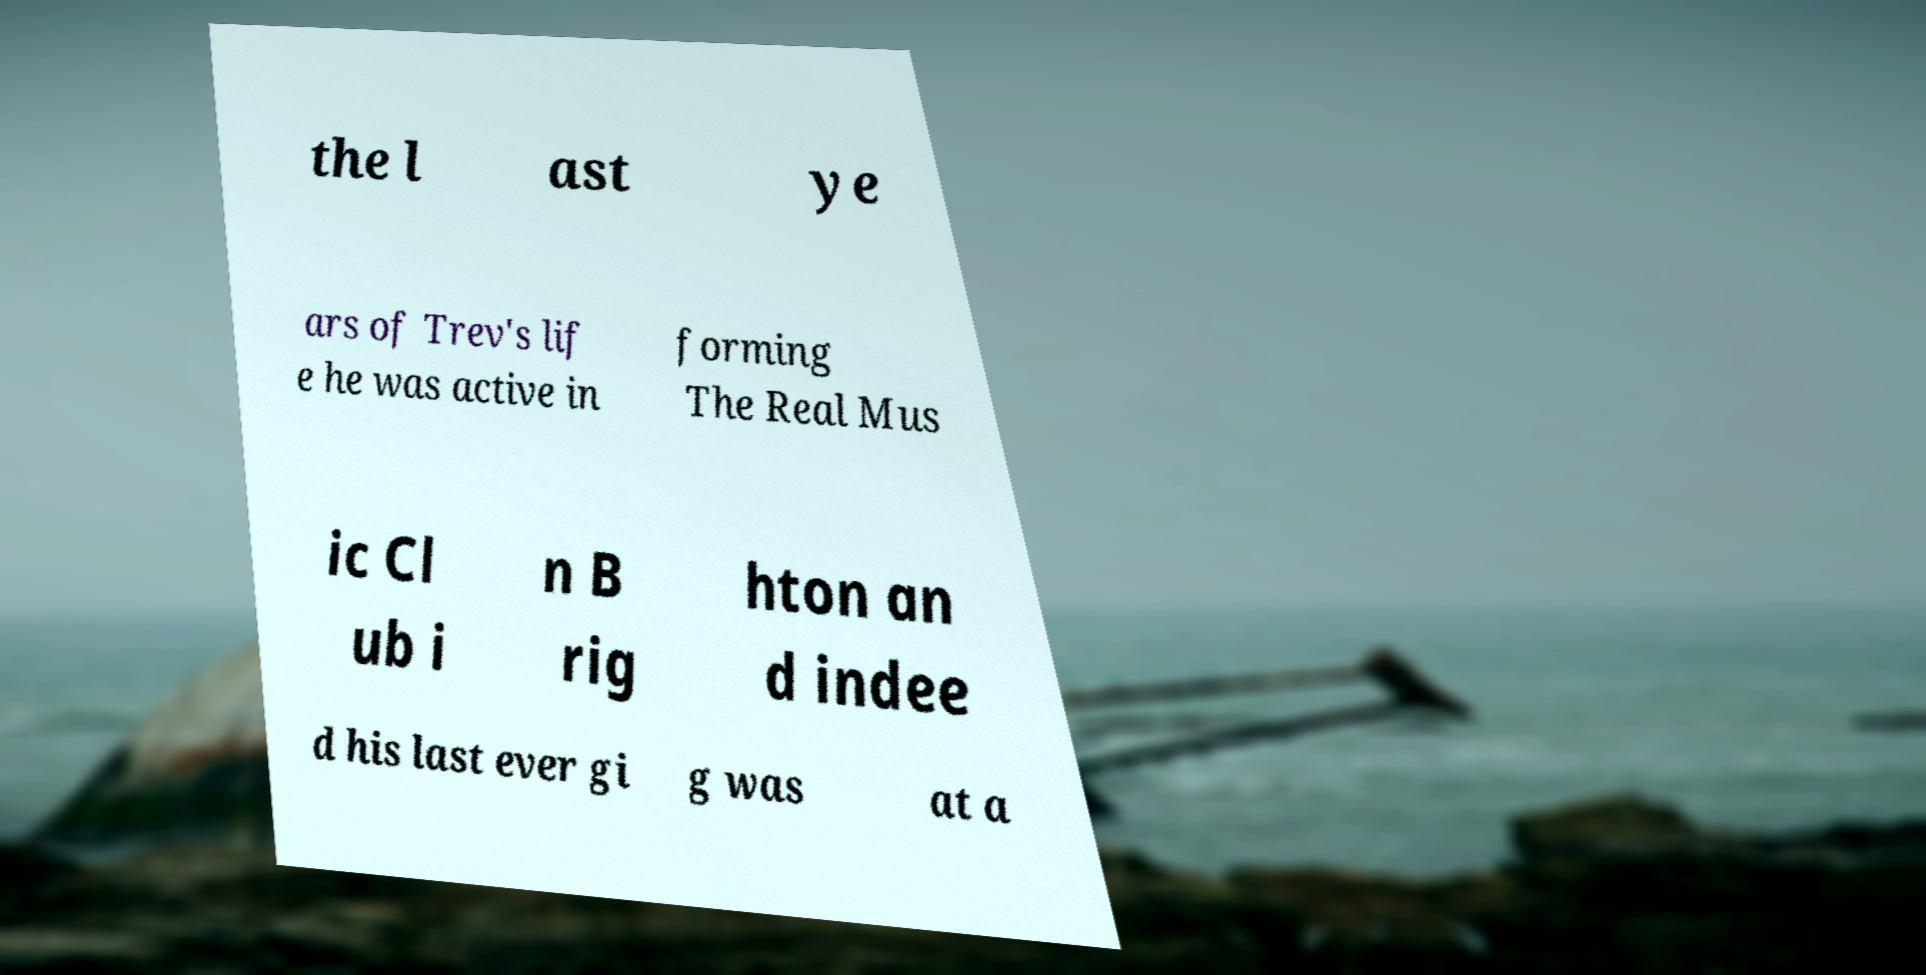For documentation purposes, I need the text within this image transcribed. Could you provide that? the l ast ye ars of Trev's lif e he was active in forming The Real Mus ic Cl ub i n B rig hton an d indee d his last ever gi g was at a 